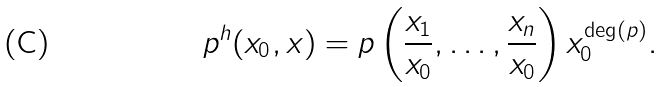<formula> <loc_0><loc_0><loc_500><loc_500>p ^ { h } ( x _ { 0 } , x ) = p \left ( \frac { x _ { 1 } } { x _ { 0 } } , \dots , \frac { x _ { n } } { x _ { 0 } } \right ) x _ { 0 } ^ { \deg ( p ) } .</formula> 